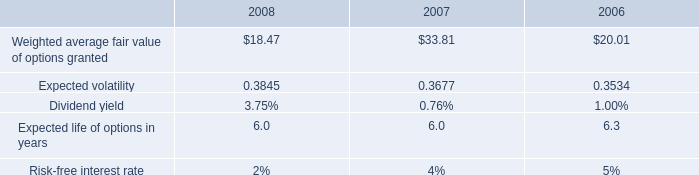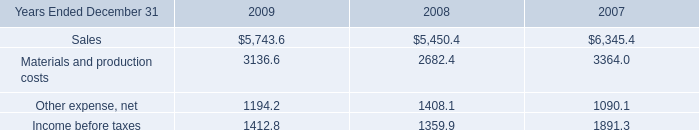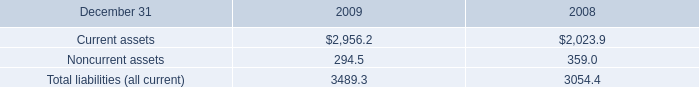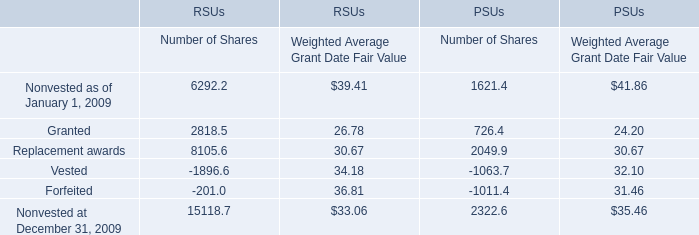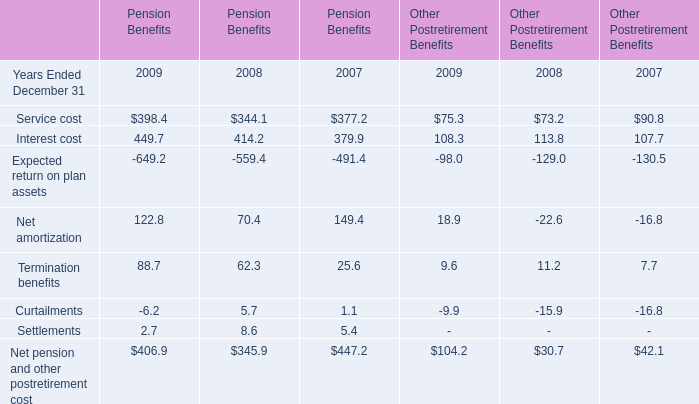Which year is Settlements the most for Pension Benefits? 
Answer: 2008. 